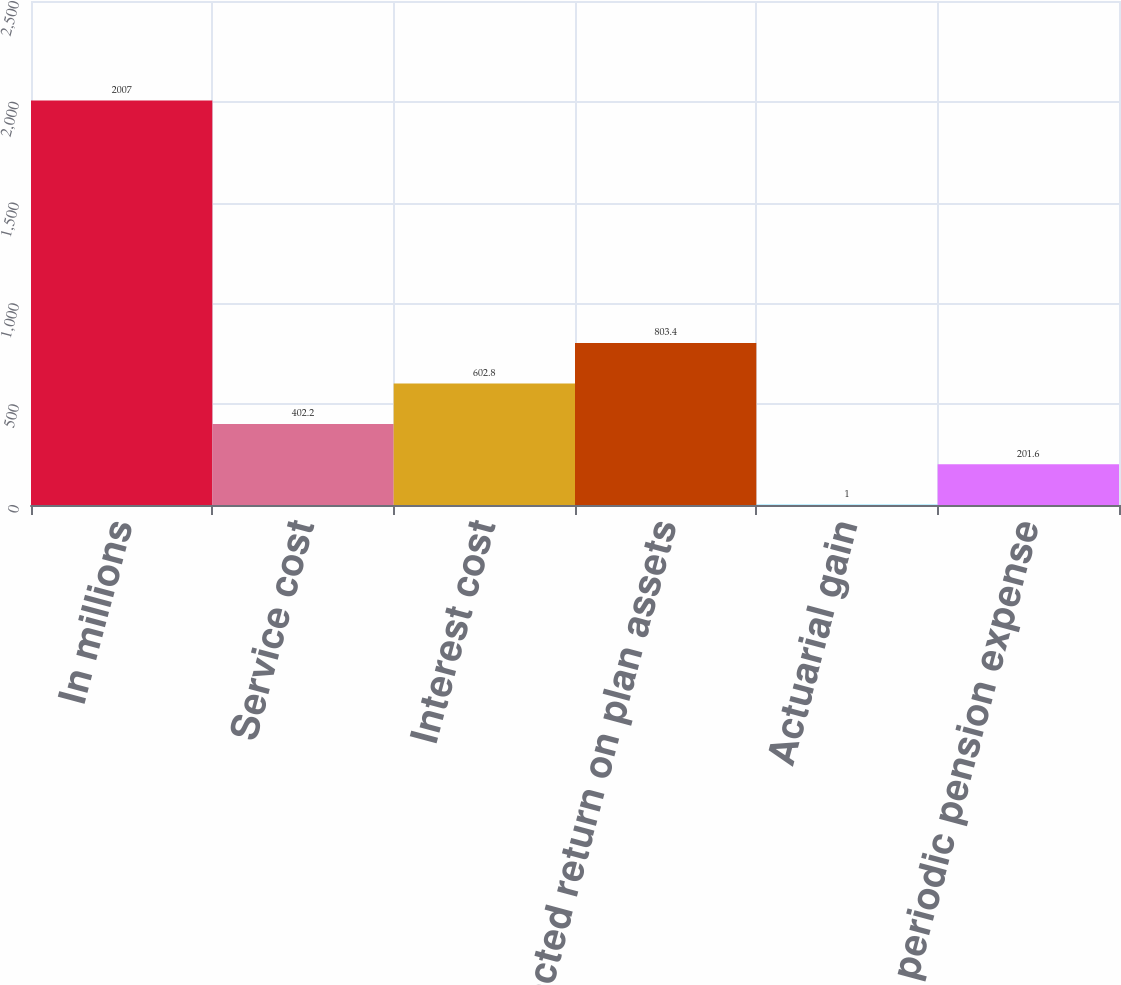Convert chart. <chart><loc_0><loc_0><loc_500><loc_500><bar_chart><fcel>In millions<fcel>Service cost<fcel>Interest cost<fcel>Expected return on plan assets<fcel>Actuarial gain<fcel>Net periodic pension expense<nl><fcel>2007<fcel>402.2<fcel>602.8<fcel>803.4<fcel>1<fcel>201.6<nl></chart> 